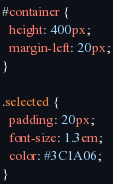<code> <loc_0><loc_0><loc_500><loc_500><_CSS_>#container {
  height: 400px;
  margin-left: 20px;
}

.selected {
  padding: 20px;
  font-size: 1.3em;
  color: #3C1A06;
}
</code> 